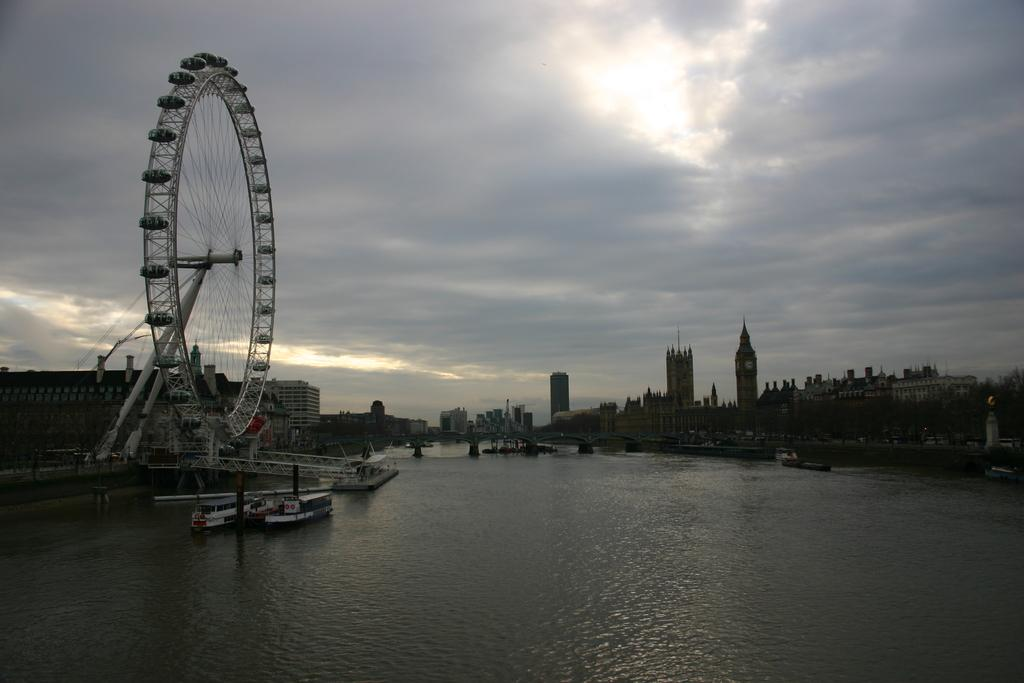What is the main feature in the image? There is a giant wheel in the image. What else can be seen in the image besides the giant wheel? There are buildings, water, boats, a cloudy sky, railings, trees, and various objects visible in the image. Can you describe the water in the image? The water is visible in the image, and there are boats present on it. What type of railings are in the image? The railings in the image are likely for safety or support purposes. What is the value of the support system in the image? There is no specific support system mentioned in the image, so it is not possible to determine its value. 